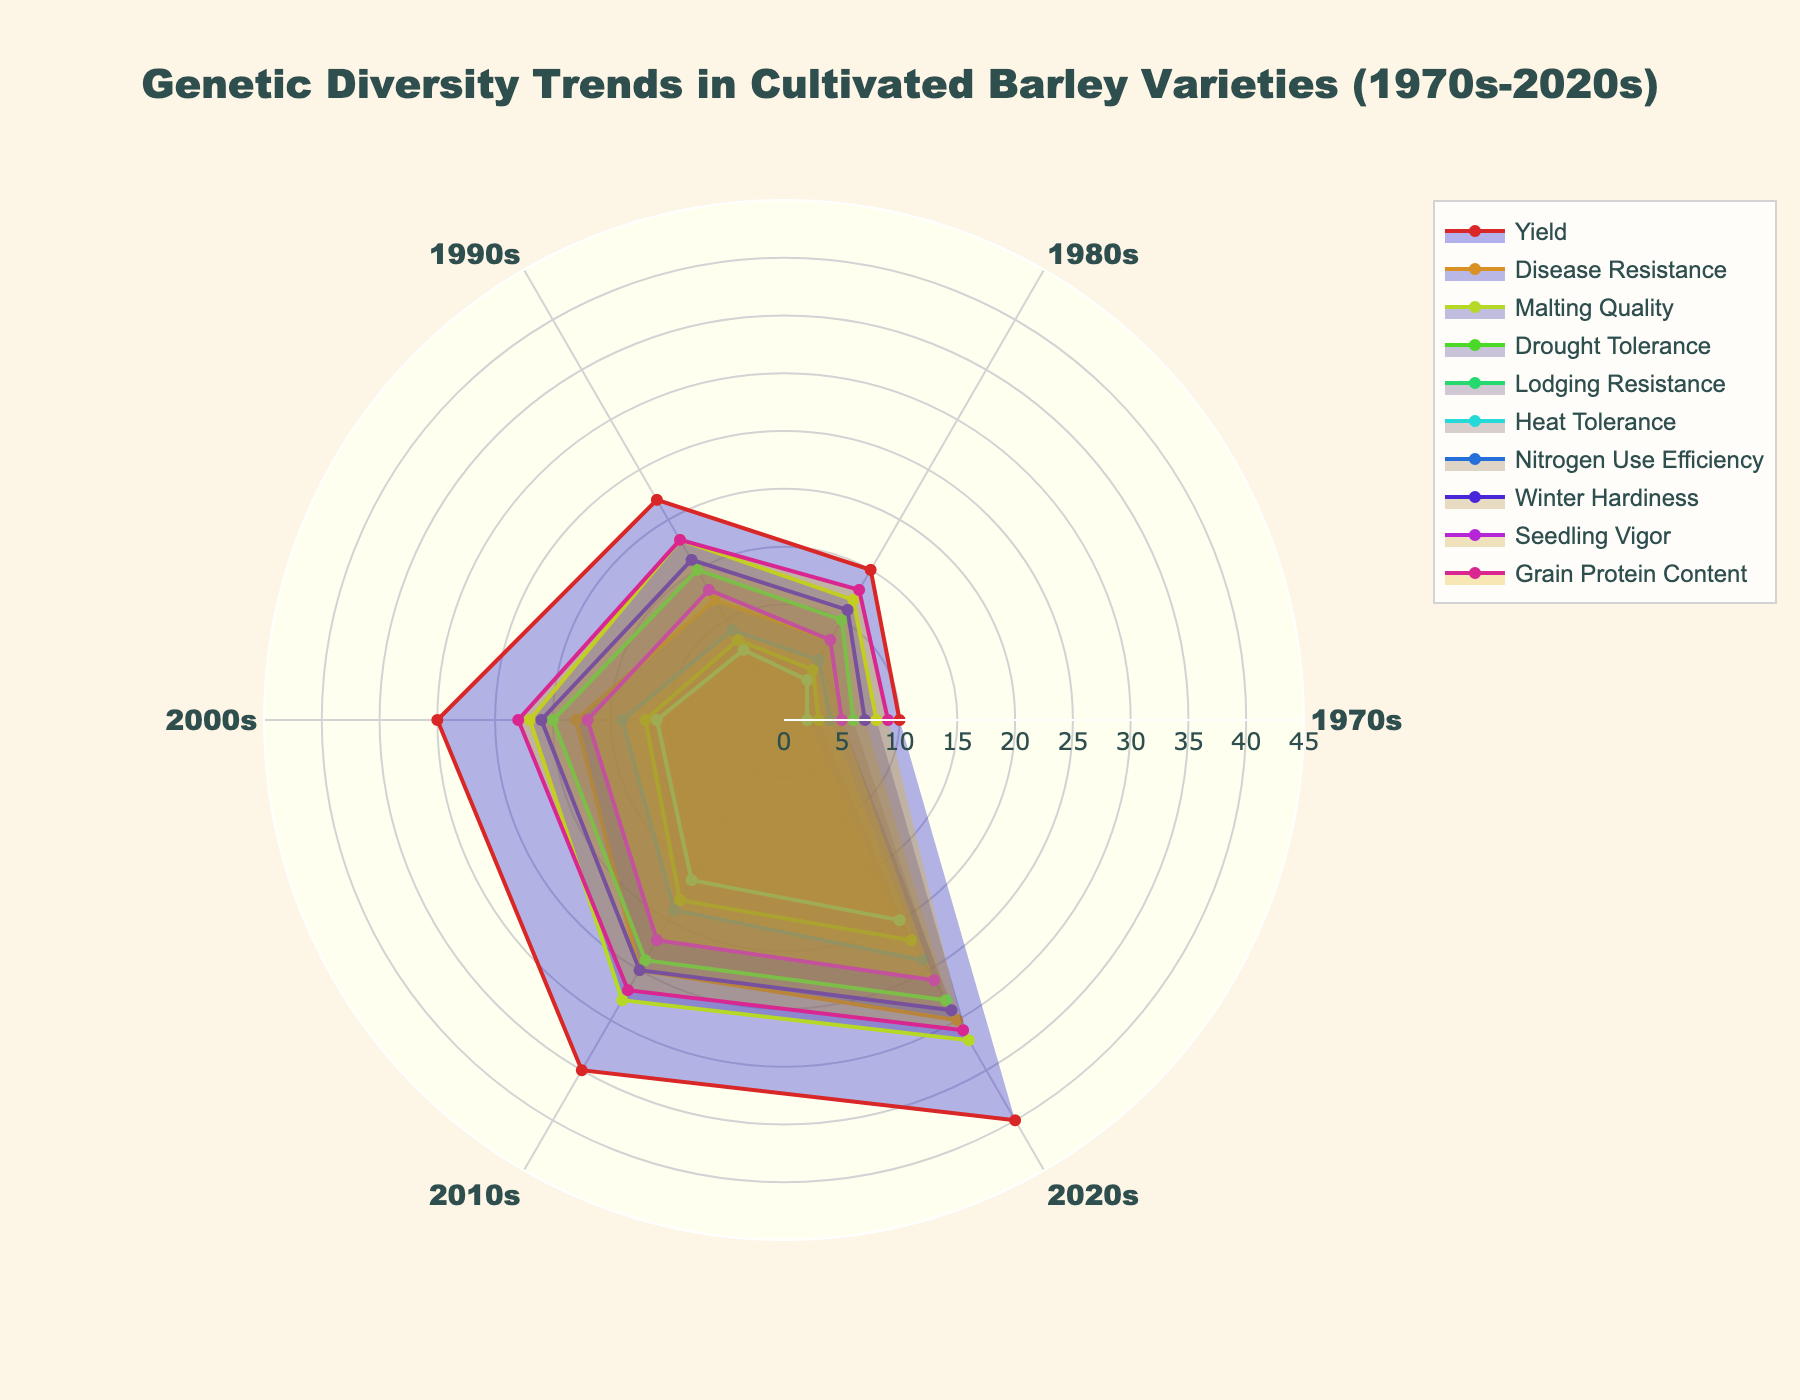what is the title of the figure? Look at the top of the figure to find the title, which is clearly specified by the plot layout.
Answer: Genetic Diversity Trends in Cultivated Barley Varieties (1970s-2020s) Which trait group has the highest genetic diversity in the 2020s? Check the radial extent for each trait in the 2020s. The group with the longest radius has the highest value.
Answer: Yield Which two trait groups have the lowest genetic diversity in the 2010s? Compare the radial length of each trait group in the 2010s. Identify the two shortest radii.
Answer: Heat Tolerance, Drought Tolerance What is the difference in genetic diversity between Yield and Grain Protein Content in the 2000s? Identify the values for Yield and Grain Protein Content in the 2000s, then subtract the latter from the former.
Answer: 7 Which trait group shows the most consistent increase in diversity over the decades? Evaluate the trend lines for each trait group, noting which has the most uniform rate of increase.
Answer: Disease Resistance By how much did the genetic diversity in Disease Resistance increase from the 1980s to the 2020s? Subtract the genetic diversity value of Disease Resistance in the 1980s from its value in the 2020s.
Answer: 22 Which trait group had the smallest relative increase in genetic diversity from the 1970s to the 2020s? Calculate the difference for each trait group between the 1970s and 2020s, then find the group with the smallest absolute change.
Answer: Seedling Vigor If the genetic diversity of Yield increased by 5 units between each decade, what would be its expected value in the 2030s? Start with the 2020s value, then add 5 to project the 2030s value.
Answer: 45 Which three trait groups have the highest genetic diversity in the 1990s? Compare the radial lengths for the decade of the 1990s across all trait groups and identify the three longest.
Answer: Yield, Malting Quality, Grain Protein Content How does the genetic diversity of Lodging Resistance in the 2010s compare to that of Drought Tolerance in the same decade? Compare the values for Lodging Resistance and Drought Tolerance in the 2010s.
Answer: Lodging Resistance is higher 